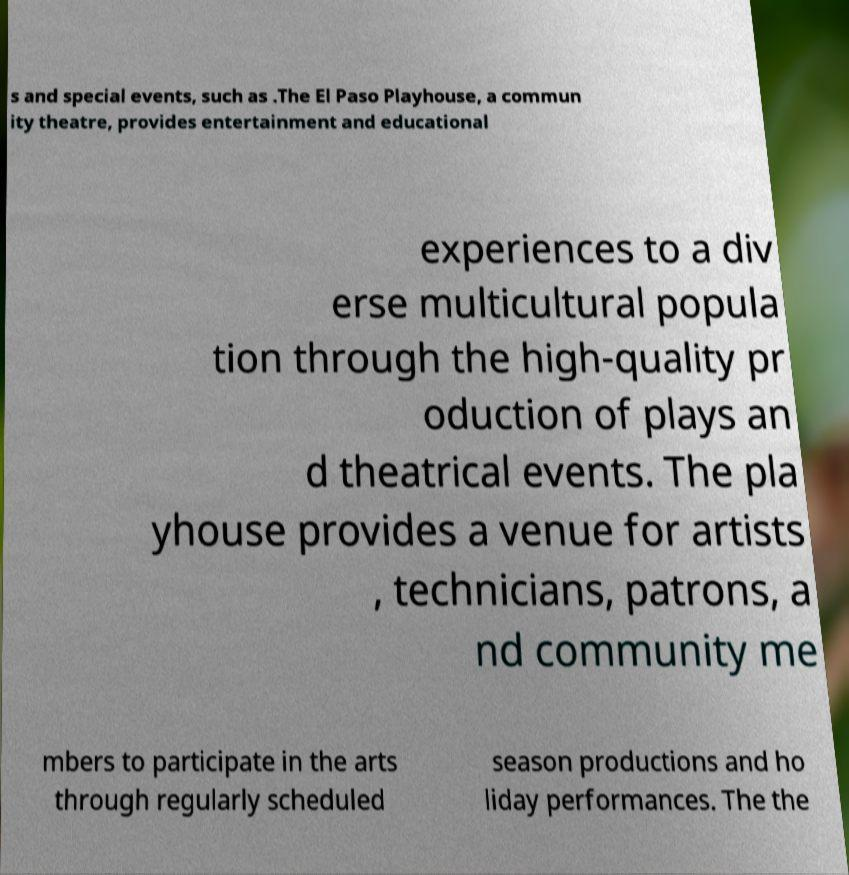Could you extract and type out the text from this image? s and special events, such as .The El Paso Playhouse, a commun ity theatre, provides entertainment and educational experiences to a div erse multicultural popula tion through the high-quality pr oduction of plays an d theatrical events. The pla yhouse provides a venue for artists , technicians, patrons, a nd community me mbers to participate in the arts through regularly scheduled season productions and ho liday performances. The the 